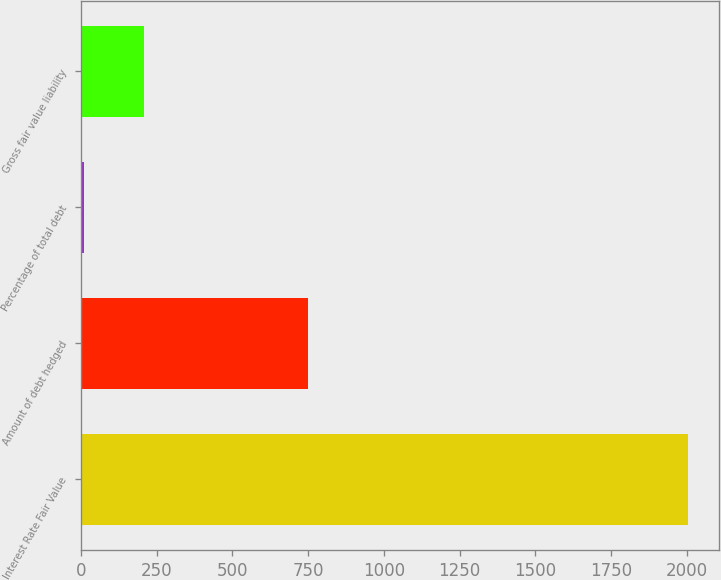<chart> <loc_0><loc_0><loc_500><loc_500><bar_chart><fcel>Interest Rate Fair Value<fcel>Amount of debt hedged<fcel>Percentage of total debt<fcel>Gross fair value liability<nl><fcel>2005<fcel>750<fcel>10<fcel>209.5<nl></chart> 